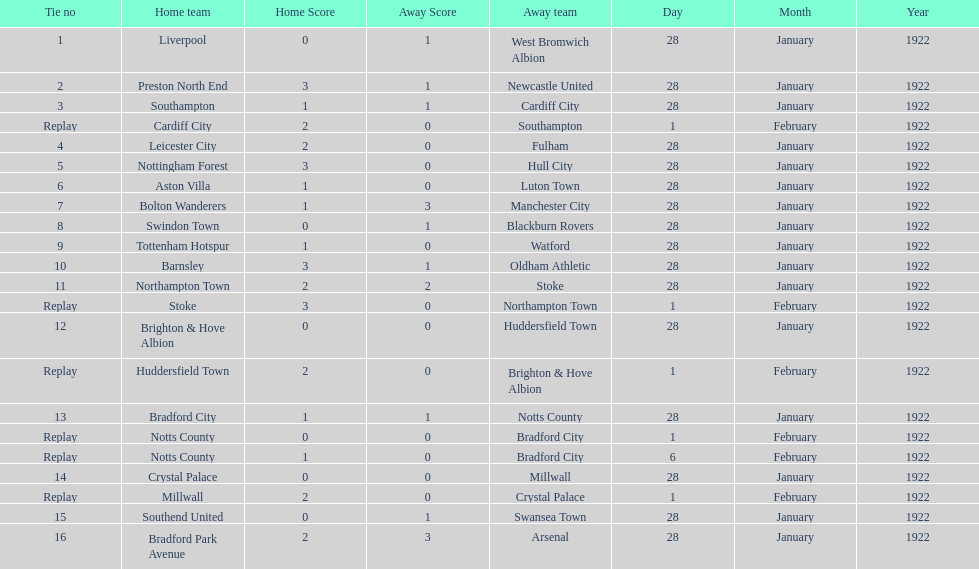What are all of the home teams? Liverpool, Preston North End, Southampton, Cardiff City, Leicester City, Nottingham Forest, Aston Villa, Bolton Wanderers, Swindon Town, Tottenham Hotspur, Barnsley, Northampton Town, Stoke, Brighton & Hove Albion, Huddersfield Town, Bradford City, Notts County, Notts County, Crystal Palace, Millwall, Southend United, Bradford Park Avenue. What were the scores? 0–1, 3–1, 1–1, 2–0, 2–0, 3–0, 1–0, 1–3, 0–1, 1–0, 3–1, 2–2, 3–0, 0–0, 2–0, 1–1, 0–0, 1–0, 0–0, 2–0, 0–1, 2–3. On which dates did they play? 28 January 1922, 28 January 1922, 28 January 1922, 1 February 1922, 28 January 1922, 28 January 1922, 28 January 1922, 28 January 1922, 28 January 1922, 28 January 1922, 28 January 1922, 28 January 1922, 1 February 1922, 28 January 1922, 1 February 1922, 28 January 1922, 1 February 1922, 6 February 1922, 28 January 1922, 1 February 1922, 28 January 1922, 28 January 1922. Which teams played on 28 january 1922? Liverpool, Preston North End, Southampton, Leicester City, Nottingham Forest, Aston Villa, Bolton Wanderers, Swindon Town, Tottenham Hotspur, Barnsley, Northampton Town, Brighton & Hove Albion, Bradford City, Crystal Palace, Southend United, Bradford Park Avenue. Of those, which scored the same as aston villa? Tottenham Hotspur. 